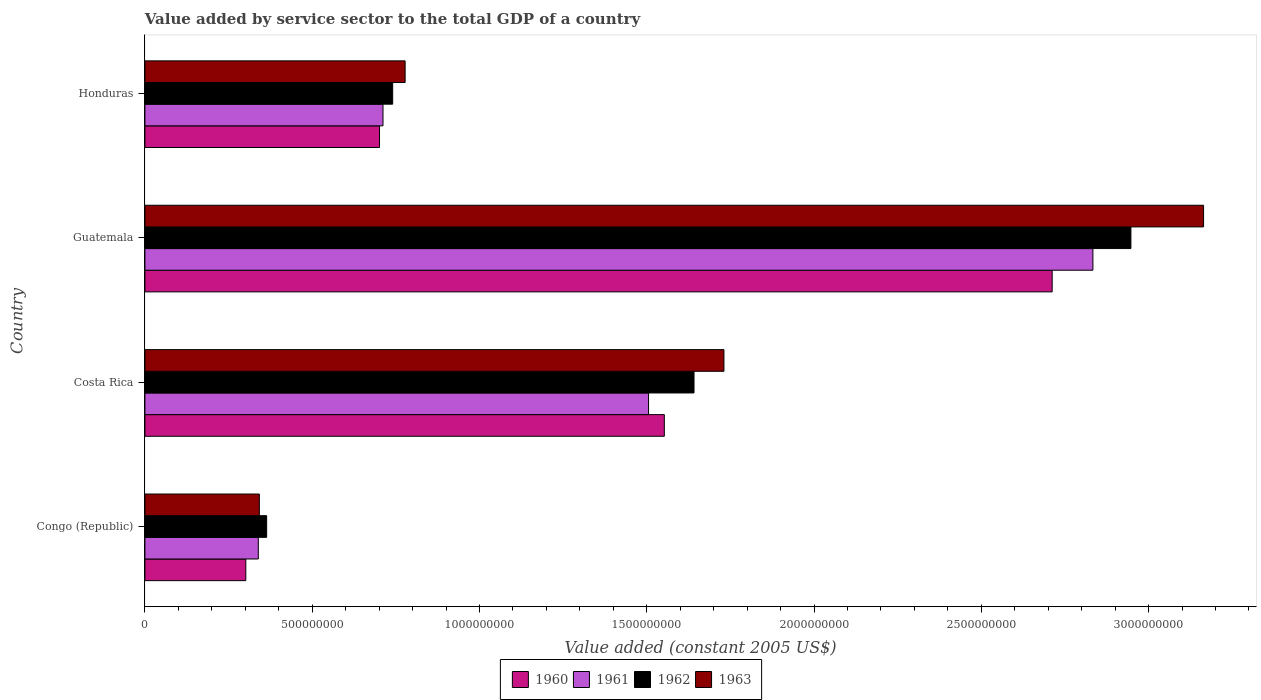How many different coloured bars are there?
Give a very brief answer. 4. Are the number of bars per tick equal to the number of legend labels?
Offer a terse response. Yes. How many bars are there on the 4th tick from the bottom?
Make the answer very short. 4. What is the label of the 2nd group of bars from the top?
Keep it short and to the point. Guatemala. In how many cases, is the number of bars for a given country not equal to the number of legend labels?
Give a very brief answer. 0. What is the value added by service sector in 1962 in Honduras?
Your answer should be very brief. 7.41e+08. Across all countries, what is the maximum value added by service sector in 1960?
Your response must be concise. 2.71e+09. Across all countries, what is the minimum value added by service sector in 1961?
Provide a short and direct response. 3.39e+08. In which country was the value added by service sector in 1962 maximum?
Your response must be concise. Guatemala. In which country was the value added by service sector in 1963 minimum?
Your response must be concise. Congo (Republic). What is the total value added by service sector in 1962 in the graph?
Provide a succinct answer. 5.69e+09. What is the difference between the value added by service sector in 1960 in Congo (Republic) and that in Costa Rica?
Offer a terse response. -1.25e+09. What is the difference between the value added by service sector in 1962 in Honduras and the value added by service sector in 1961 in Costa Rica?
Offer a very short reply. -7.65e+08. What is the average value added by service sector in 1962 per country?
Your answer should be very brief. 1.42e+09. What is the difference between the value added by service sector in 1962 and value added by service sector in 1960 in Congo (Republic)?
Ensure brevity in your answer.  6.23e+07. In how many countries, is the value added by service sector in 1962 greater than 1000000000 US$?
Provide a short and direct response. 2. What is the ratio of the value added by service sector in 1961 in Congo (Republic) to that in Costa Rica?
Provide a short and direct response. 0.23. Is the difference between the value added by service sector in 1962 in Congo (Republic) and Guatemala greater than the difference between the value added by service sector in 1960 in Congo (Republic) and Guatemala?
Your response must be concise. No. What is the difference between the highest and the second highest value added by service sector in 1962?
Offer a very short reply. 1.31e+09. What is the difference between the highest and the lowest value added by service sector in 1962?
Give a very brief answer. 2.58e+09. Is the sum of the value added by service sector in 1962 in Congo (Republic) and Costa Rica greater than the maximum value added by service sector in 1961 across all countries?
Provide a short and direct response. No. Is it the case that in every country, the sum of the value added by service sector in 1963 and value added by service sector in 1962 is greater than the sum of value added by service sector in 1960 and value added by service sector in 1961?
Offer a terse response. No. Is it the case that in every country, the sum of the value added by service sector in 1960 and value added by service sector in 1962 is greater than the value added by service sector in 1961?
Keep it short and to the point. Yes. How many bars are there?
Ensure brevity in your answer.  16. Are all the bars in the graph horizontal?
Offer a very short reply. Yes. How many countries are there in the graph?
Give a very brief answer. 4. Are the values on the major ticks of X-axis written in scientific E-notation?
Make the answer very short. No. Does the graph contain any zero values?
Your response must be concise. No. Does the graph contain grids?
Provide a short and direct response. No. How are the legend labels stacked?
Provide a succinct answer. Horizontal. What is the title of the graph?
Your answer should be very brief. Value added by service sector to the total GDP of a country. Does "1961" appear as one of the legend labels in the graph?
Offer a terse response. Yes. What is the label or title of the X-axis?
Make the answer very short. Value added (constant 2005 US$). What is the label or title of the Y-axis?
Keep it short and to the point. Country. What is the Value added (constant 2005 US$) of 1960 in Congo (Republic)?
Your answer should be very brief. 3.02e+08. What is the Value added (constant 2005 US$) in 1961 in Congo (Republic)?
Your response must be concise. 3.39e+08. What is the Value added (constant 2005 US$) in 1962 in Congo (Republic)?
Make the answer very short. 3.64e+08. What is the Value added (constant 2005 US$) of 1963 in Congo (Republic)?
Ensure brevity in your answer.  3.42e+08. What is the Value added (constant 2005 US$) of 1960 in Costa Rica?
Provide a succinct answer. 1.55e+09. What is the Value added (constant 2005 US$) in 1961 in Costa Rica?
Provide a succinct answer. 1.51e+09. What is the Value added (constant 2005 US$) of 1962 in Costa Rica?
Ensure brevity in your answer.  1.64e+09. What is the Value added (constant 2005 US$) of 1963 in Costa Rica?
Offer a terse response. 1.73e+09. What is the Value added (constant 2005 US$) in 1960 in Guatemala?
Make the answer very short. 2.71e+09. What is the Value added (constant 2005 US$) of 1961 in Guatemala?
Provide a short and direct response. 2.83e+09. What is the Value added (constant 2005 US$) in 1962 in Guatemala?
Provide a short and direct response. 2.95e+09. What is the Value added (constant 2005 US$) in 1963 in Guatemala?
Give a very brief answer. 3.16e+09. What is the Value added (constant 2005 US$) in 1960 in Honduras?
Provide a short and direct response. 7.01e+08. What is the Value added (constant 2005 US$) of 1961 in Honduras?
Give a very brief answer. 7.12e+08. What is the Value added (constant 2005 US$) in 1962 in Honduras?
Your response must be concise. 7.41e+08. What is the Value added (constant 2005 US$) in 1963 in Honduras?
Offer a very short reply. 7.78e+08. Across all countries, what is the maximum Value added (constant 2005 US$) of 1960?
Your answer should be compact. 2.71e+09. Across all countries, what is the maximum Value added (constant 2005 US$) of 1961?
Provide a short and direct response. 2.83e+09. Across all countries, what is the maximum Value added (constant 2005 US$) of 1962?
Offer a very short reply. 2.95e+09. Across all countries, what is the maximum Value added (constant 2005 US$) of 1963?
Offer a terse response. 3.16e+09. Across all countries, what is the minimum Value added (constant 2005 US$) of 1960?
Provide a succinct answer. 3.02e+08. Across all countries, what is the minimum Value added (constant 2005 US$) in 1961?
Provide a short and direct response. 3.39e+08. Across all countries, what is the minimum Value added (constant 2005 US$) of 1962?
Offer a very short reply. 3.64e+08. Across all countries, what is the minimum Value added (constant 2005 US$) of 1963?
Offer a terse response. 3.42e+08. What is the total Value added (constant 2005 US$) in 1960 in the graph?
Offer a very short reply. 5.27e+09. What is the total Value added (constant 2005 US$) in 1961 in the graph?
Keep it short and to the point. 5.39e+09. What is the total Value added (constant 2005 US$) of 1962 in the graph?
Give a very brief answer. 5.69e+09. What is the total Value added (constant 2005 US$) in 1963 in the graph?
Your answer should be compact. 6.01e+09. What is the difference between the Value added (constant 2005 US$) in 1960 in Congo (Republic) and that in Costa Rica?
Give a very brief answer. -1.25e+09. What is the difference between the Value added (constant 2005 US$) of 1961 in Congo (Republic) and that in Costa Rica?
Offer a very short reply. -1.17e+09. What is the difference between the Value added (constant 2005 US$) of 1962 in Congo (Republic) and that in Costa Rica?
Offer a terse response. -1.28e+09. What is the difference between the Value added (constant 2005 US$) in 1963 in Congo (Republic) and that in Costa Rica?
Offer a terse response. -1.39e+09. What is the difference between the Value added (constant 2005 US$) in 1960 in Congo (Republic) and that in Guatemala?
Offer a very short reply. -2.41e+09. What is the difference between the Value added (constant 2005 US$) of 1961 in Congo (Republic) and that in Guatemala?
Keep it short and to the point. -2.49e+09. What is the difference between the Value added (constant 2005 US$) of 1962 in Congo (Republic) and that in Guatemala?
Ensure brevity in your answer.  -2.58e+09. What is the difference between the Value added (constant 2005 US$) of 1963 in Congo (Republic) and that in Guatemala?
Provide a short and direct response. -2.82e+09. What is the difference between the Value added (constant 2005 US$) in 1960 in Congo (Republic) and that in Honduras?
Offer a terse response. -4.00e+08. What is the difference between the Value added (constant 2005 US$) in 1961 in Congo (Republic) and that in Honduras?
Keep it short and to the point. -3.73e+08. What is the difference between the Value added (constant 2005 US$) of 1962 in Congo (Republic) and that in Honduras?
Your answer should be compact. -3.77e+08. What is the difference between the Value added (constant 2005 US$) in 1963 in Congo (Republic) and that in Honduras?
Ensure brevity in your answer.  -4.36e+08. What is the difference between the Value added (constant 2005 US$) of 1960 in Costa Rica and that in Guatemala?
Your answer should be very brief. -1.16e+09. What is the difference between the Value added (constant 2005 US$) of 1961 in Costa Rica and that in Guatemala?
Your answer should be compact. -1.33e+09. What is the difference between the Value added (constant 2005 US$) in 1962 in Costa Rica and that in Guatemala?
Offer a very short reply. -1.31e+09. What is the difference between the Value added (constant 2005 US$) in 1963 in Costa Rica and that in Guatemala?
Your answer should be very brief. -1.43e+09. What is the difference between the Value added (constant 2005 US$) of 1960 in Costa Rica and that in Honduras?
Provide a short and direct response. 8.51e+08. What is the difference between the Value added (constant 2005 US$) in 1961 in Costa Rica and that in Honduras?
Offer a terse response. 7.94e+08. What is the difference between the Value added (constant 2005 US$) of 1962 in Costa Rica and that in Honduras?
Keep it short and to the point. 9.01e+08. What is the difference between the Value added (constant 2005 US$) of 1963 in Costa Rica and that in Honduras?
Your response must be concise. 9.53e+08. What is the difference between the Value added (constant 2005 US$) of 1960 in Guatemala and that in Honduras?
Make the answer very short. 2.01e+09. What is the difference between the Value added (constant 2005 US$) in 1961 in Guatemala and that in Honduras?
Your answer should be very brief. 2.12e+09. What is the difference between the Value added (constant 2005 US$) in 1962 in Guatemala and that in Honduras?
Offer a very short reply. 2.21e+09. What is the difference between the Value added (constant 2005 US$) of 1963 in Guatemala and that in Honduras?
Provide a short and direct response. 2.39e+09. What is the difference between the Value added (constant 2005 US$) of 1960 in Congo (Republic) and the Value added (constant 2005 US$) of 1961 in Costa Rica?
Your answer should be compact. -1.20e+09. What is the difference between the Value added (constant 2005 US$) of 1960 in Congo (Republic) and the Value added (constant 2005 US$) of 1962 in Costa Rica?
Give a very brief answer. -1.34e+09. What is the difference between the Value added (constant 2005 US$) in 1960 in Congo (Republic) and the Value added (constant 2005 US$) in 1963 in Costa Rica?
Provide a succinct answer. -1.43e+09. What is the difference between the Value added (constant 2005 US$) in 1961 in Congo (Republic) and the Value added (constant 2005 US$) in 1962 in Costa Rica?
Your response must be concise. -1.30e+09. What is the difference between the Value added (constant 2005 US$) in 1961 in Congo (Republic) and the Value added (constant 2005 US$) in 1963 in Costa Rica?
Your answer should be very brief. -1.39e+09. What is the difference between the Value added (constant 2005 US$) of 1962 in Congo (Republic) and the Value added (constant 2005 US$) of 1963 in Costa Rica?
Offer a terse response. -1.37e+09. What is the difference between the Value added (constant 2005 US$) of 1960 in Congo (Republic) and the Value added (constant 2005 US$) of 1961 in Guatemala?
Give a very brief answer. -2.53e+09. What is the difference between the Value added (constant 2005 US$) in 1960 in Congo (Republic) and the Value added (constant 2005 US$) in 1962 in Guatemala?
Your response must be concise. -2.65e+09. What is the difference between the Value added (constant 2005 US$) in 1960 in Congo (Republic) and the Value added (constant 2005 US$) in 1963 in Guatemala?
Keep it short and to the point. -2.86e+09. What is the difference between the Value added (constant 2005 US$) of 1961 in Congo (Republic) and the Value added (constant 2005 US$) of 1962 in Guatemala?
Your response must be concise. -2.61e+09. What is the difference between the Value added (constant 2005 US$) in 1961 in Congo (Republic) and the Value added (constant 2005 US$) in 1963 in Guatemala?
Keep it short and to the point. -2.83e+09. What is the difference between the Value added (constant 2005 US$) in 1962 in Congo (Republic) and the Value added (constant 2005 US$) in 1963 in Guatemala?
Ensure brevity in your answer.  -2.80e+09. What is the difference between the Value added (constant 2005 US$) of 1960 in Congo (Republic) and the Value added (constant 2005 US$) of 1961 in Honduras?
Give a very brief answer. -4.10e+08. What is the difference between the Value added (constant 2005 US$) in 1960 in Congo (Republic) and the Value added (constant 2005 US$) in 1962 in Honduras?
Your response must be concise. -4.39e+08. What is the difference between the Value added (constant 2005 US$) of 1960 in Congo (Republic) and the Value added (constant 2005 US$) of 1963 in Honduras?
Provide a short and direct response. -4.76e+08. What is the difference between the Value added (constant 2005 US$) in 1961 in Congo (Republic) and the Value added (constant 2005 US$) in 1962 in Honduras?
Provide a short and direct response. -4.02e+08. What is the difference between the Value added (constant 2005 US$) in 1961 in Congo (Republic) and the Value added (constant 2005 US$) in 1963 in Honduras?
Make the answer very short. -4.39e+08. What is the difference between the Value added (constant 2005 US$) in 1962 in Congo (Republic) and the Value added (constant 2005 US$) in 1963 in Honduras?
Your answer should be very brief. -4.14e+08. What is the difference between the Value added (constant 2005 US$) of 1960 in Costa Rica and the Value added (constant 2005 US$) of 1961 in Guatemala?
Offer a very short reply. -1.28e+09. What is the difference between the Value added (constant 2005 US$) in 1960 in Costa Rica and the Value added (constant 2005 US$) in 1962 in Guatemala?
Your answer should be compact. -1.39e+09. What is the difference between the Value added (constant 2005 US$) of 1960 in Costa Rica and the Value added (constant 2005 US$) of 1963 in Guatemala?
Keep it short and to the point. -1.61e+09. What is the difference between the Value added (constant 2005 US$) in 1961 in Costa Rica and the Value added (constant 2005 US$) in 1962 in Guatemala?
Make the answer very short. -1.44e+09. What is the difference between the Value added (constant 2005 US$) in 1961 in Costa Rica and the Value added (constant 2005 US$) in 1963 in Guatemala?
Offer a very short reply. -1.66e+09. What is the difference between the Value added (constant 2005 US$) in 1962 in Costa Rica and the Value added (constant 2005 US$) in 1963 in Guatemala?
Offer a terse response. -1.52e+09. What is the difference between the Value added (constant 2005 US$) of 1960 in Costa Rica and the Value added (constant 2005 US$) of 1961 in Honduras?
Provide a short and direct response. 8.41e+08. What is the difference between the Value added (constant 2005 US$) of 1960 in Costa Rica and the Value added (constant 2005 US$) of 1962 in Honduras?
Make the answer very short. 8.12e+08. What is the difference between the Value added (constant 2005 US$) in 1960 in Costa Rica and the Value added (constant 2005 US$) in 1963 in Honduras?
Ensure brevity in your answer.  7.75e+08. What is the difference between the Value added (constant 2005 US$) of 1961 in Costa Rica and the Value added (constant 2005 US$) of 1962 in Honduras?
Ensure brevity in your answer.  7.65e+08. What is the difference between the Value added (constant 2005 US$) of 1961 in Costa Rica and the Value added (constant 2005 US$) of 1963 in Honduras?
Ensure brevity in your answer.  7.28e+08. What is the difference between the Value added (constant 2005 US$) of 1962 in Costa Rica and the Value added (constant 2005 US$) of 1963 in Honduras?
Provide a short and direct response. 8.63e+08. What is the difference between the Value added (constant 2005 US$) in 1960 in Guatemala and the Value added (constant 2005 US$) in 1961 in Honduras?
Your response must be concise. 2.00e+09. What is the difference between the Value added (constant 2005 US$) in 1960 in Guatemala and the Value added (constant 2005 US$) in 1962 in Honduras?
Your answer should be very brief. 1.97e+09. What is the difference between the Value added (constant 2005 US$) in 1960 in Guatemala and the Value added (constant 2005 US$) in 1963 in Honduras?
Give a very brief answer. 1.93e+09. What is the difference between the Value added (constant 2005 US$) of 1961 in Guatemala and the Value added (constant 2005 US$) of 1962 in Honduras?
Your answer should be compact. 2.09e+09. What is the difference between the Value added (constant 2005 US$) of 1961 in Guatemala and the Value added (constant 2005 US$) of 1963 in Honduras?
Your response must be concise. 2.06e+09. What is the difference between the Value added (constant 2005 US$) of 1962 in Guatemala and the Value added (constant 2005 US$) of 1963 in Honduras?
Provide a succinct answer. 2.17e+09. What is the average Value added (constant 2005 US$) in 1960 per country?
Give a very brief answer. 1.32e+09. What is the average Value added (constant 2005 US$) of 1961 per country?
Your answer should be compact. 1.35e+09. What is the average Value added (constant 2005 US$) in 1962 per country?
Your answer should be very brief. 1.42e+09. What is the average Value added (constant 2005 US$) in 1963 per country?
Your response must be concise. 1.50e+09. What is the difference between the Value added (constant 2005 US$) in 1960 and Value added (constant 2005 US$) in 1961 in Congo (Republic)?
Ensure brevity in your answer.  -3.74e+07. What is the difference between the Value added (constant 2005 US$) in 1960 and Value added (constant 2005 US$) in 1962 in Congo (Republic)?
Ensure brevity in your answer.  -6.23e+07. What is the difference between the Value added (constant 2005 US$) in 1960 and Value added (constant 2005 US$) in 1963 in Congo (Republic)?
Provide a succinct answer. -4.05e+07. What is the difference between the Value added (constant 2005 US$) in 1961 and Value added (constant 2005 US$) in 1962 in Congo (Republic)?
Make the answer very short. -2.49e+07. What is the difference between the Value added (constant 2005 US$) of 1961 and Value added (constant 2005 US$) of 1963 in Congo (Republic)?
Give a very brief answer. -3.09e+06. What is the difference between the Value added (constant 2005 US$) in 1962 and Value added (constant 2005 US$) in 1963 in Congo (Republic)?
Make the answer very short. 2.18e+07. What is the difference between the Value added (constant 2005 US$) in 1960 and Value added (constant 2005 US$) in 1961 in Costa Rica?
Ensure brevity in your answer.  4.72e+07. What is the difference between the Value added (constant 2005 US$) of 1960 and Value added (constant 2005 US$) of 1962 in Costa Rica?
Keep it short and to the point. -8.87e+07. What is the difference between the Value added (constant 2005 US$) of 1960 and Value added (constant 2005 US$) of 1963 in Costa Rica?
Provide a short and direct response. -1.78e+08. What is the difference between the Value added (constant 2005 US$) of 1961 and Value added (constant 2005 US$) of 1962 in Costa Rica?
Your answer should be very brief. -1.36e+08. What is the difference between the Value added (constant 2005 US$) in 1961 and Value added (constant 2005 US$) in 1963 in Costa Rica?
Keep it short and to the point. -2.25e+08. What is the difference between the Value added (constant 2005 US$) in 1962 and Value added (constant 2005 US$) in 1963 in Costa Rica?
Give a very brief answer. -8.94e+07. What is the difference between the Value added (constant 2005 US$) of 1960 and Value added (constant 2005 US$) of 1961 in Guatemala?
Your answer should be compact. -1.22e+08. What is the difference between the Value added (constant 2005 US$) of 1960 and Value added (constant 2005 US$) of 1962 in Guatemala?
Your answer should be compact. -2.35e+08. What is the difference between the Value added (constant 2005 US$) in 1960 and Value added (constant 2005 US$) in 1963 in Guatemala?
Make the answer very short. -4.53e+08. What is the difference between the Value added (constant 2005 US$) of 1961 and Value added (constant 2005 US$) of 1962 in Guatemala?
Your answer should be compact. -1.14e+08. What is the difference between the Value added (constant 2005 US$) in 1961 and Value added (constant 2005 US$) in 1963 in Guatemala?
Your answer should be very brief. -3.31e+08. What is the difference between the Value added (constant 2005 US$) of 1962 and Value added (constant 2005 US$) of 1963 in Guatemala?
Your answer should be compact. -2.17e+08. What is the difference between the Value added (constant 2005 US$) in 1960 and Value added (constant 2005 US$) in 1961 in Honduras?
Provide a succinct answer. -1.04e+07. What is the difference between the Value added (constant 2005 US$) in 1960 and Value added (constant 2005 US$) in 1962 in Honduras?
Your answer should be compact. -3.93e+07. What is the difference between the Value added (constant 2005 US$) of 1960 and Value added (constant 2005 US$) of 1963 in Honduras?
Give a very brief answer. -7.65e+07. What is the difference between the Value added (constant 2005 US$) of 1961 and Value added (constant 2005 US$) of 1962 in Honduras?
Your answer should be very brief. -2.89e+07. What is the difference between the Value added (constant 2005 US$) of 1961 and Value added (constant 2005 US$) of 1963 in Honduras?
Give a very brief answer. -6.62e+07. What is the difference between the Value added (constant 2005 US$) of 1962 and Value added (constant 2005 US$) of 1963 in Honduras?
Provide a succinct answer. -3.72e+07. What is the ratio of the Value added (constant 2005 US$) in 1960 in Congo (Republic) to that in Costa Rica?
Provide a short and direct response. 0.19. What is the ratio of the Value added (constant 2005 US$) of 1961 in Congo (Republic) to that in Costa Rica?
Provide a succinct answer. 0.23. What is the ratio of the Value added (constant 2005 US$) in 1962 in Congo (Republic) to that in Costa Rica?
Your response must be concise. 0.22. What is the ratio of the Value added (constant 2005 US$) of 1963 in Congo (Republic) to that in Costa Rica?
Offer a very short reply. 0.2. What is the ratio of the Value added (constant 2005 US$) in 1960 in Congo (Republic) to that in Guatemala?
Provide a succinct answer. 0.11. What is the ratio of the Value added (constant 2005 US$) in 1961 in Congo (Republic) to that in Guatemala?
Give a very brief answer. 0.12. What is the ratio of the Value added (constant 2005 US$) in 1962 in Congo (Republic) to that in Guatemala?
Keep it short and to the point. 0.12. What is the ratio of the Value added (constant 2005 US$) in 1963 in Congo (Republic) to that in Guatemala?
Provide a succinct answer. 0.11. What is the ratio of the Value added (constant 2005 US$) in 1960 in Congo (Republic) to that in Honduras?
Ensure brevity in your answer.  0.43. What is the ratio of the Value added (constant 2005 US$) in 1961 in Congo (Republic) to that in Honduras?
Your answer should be compact. 0.48. What is the ratio of the Value added (constant 2005 US$) in 1962 in Congo (Republic) to that in Honduras?
Provide a succinct answer. 0.49. What is the ratio of the Value added (constant 2005 US$) of 1963 in Congo (Republic) to that in Honduras?
Your response must be concise. 0.44. What is the ratio of the Value added (constant 2005 US$) in 1960 in Costa Rica to that in Guatemala?
Your answer should be very brief. 0.57. What is the ratio of the Value added (constant 2005 US$) of 1961 in Costa Rica to that in Guatemala?
Offer a terse response. 0.53. What is the ratio of the Value added (constant 2005 US$) of 1962 in Costa Rica to that in Guatemala?
Make the answer very short. 0.56. What is the ratio of the Value added (constant 2005 US$) in 1963 in Costa Rica to that in Guatemala?
Offer a terse response. 0.55. What is the ratio of the Value added (constant 2005 US$) in 1960 in Costa Rica to that in Honduras?
Make the answer very short. 2.21. What is the ratio of the Value added (constant 2005 US$) of 1961 in Costa Rica to that in Honduras?
Offer a very short reply. 2.12. What is the ratio of the Value added (constant 2005 US$) of 1962 in Costa Rica to that in Honduras?
Offer a very short reply. 2.22. What is the ratio of the Value added (constant 2005 US$) in 1963 in Costa Rica to that in Honduras?
Your answer should be very brief. 2.23. What is the ratio of the Value added (constant 2005 US$) in 1960 in Guatemala to that in Honduras?
Offer a terse response. 3.87. What is the ratio of the Value added (constant 2005 US$) of 1961 in Guatemala to that in Honduras?
Provide a succinct answer. 3.98. What is the ratio of the Value added (constant 2005 US$) of 1962 in Guatemala to that in Honduras?
Your answer should be compact. 3.98. What is the ratio of the Value added (constant 2005 US$) in 1963 in Guatemala to that in Honduras?
Provide a succinct answer. 4.07. What is the difference between the highest and the second highest Value added (constant 2005 US$) of 1960?
Ensure brevity in your answer.  1.16e+09. What is the difference between the highest and the second highest Value added (constant 2005 US$) of 1961?
Give a very brief answer. 1.33e+09. What is the difference between the highest and the second highest Value added (constant 2005 US$) of 1962?
Ensure brevity in your answer.  1.31e+09. What is the difference between the highest and the second highest Value added (constant 2005 US$) of 1963?
Offer a terse response. 1.43e+09. What is the difference between the highest and the lowest Value added (constant 2005 US$) of 1960?
Give a very brief answer. 2.41e+09. What is the difference between the highest and the lowest Value added (constant 2005 US$) in 1961?
Your answer should be very brief. 2.49e+09. What is the difference between the highest and the lowest Value added (constant 2005 US$) in 1962?
Provide a short and direct response. 2.58e+09. What is the difference between the highest and the lowest Value added (constant 2005 US$) in 1963?
Offer a very short reply. 2.82e+09. 